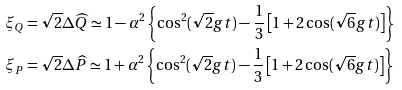Convert formula to latex. <formula><loc_0><loc_0><loc_500><loc_500>\xi _ { Q } & = \sqrt { 2 } \Delta \widehat { Q } \simeq 1 - \alpha ^ { 2 } \left \{ \cos ^ { 2 } ( \sqrt { 2 } g t ) - \frac { 1 } { 3 } \left [ 1 + 2 \cos ( \sqrt { 6 } g t ) \right ] \right \} \\ \xi _ { P } & = \sqrt { 2 } \Delta \widehat { P } \simeq 1 + \alpha ^ { 2 } \left \{ \cos ^ { 2 } ( \sqrt { 2 } g t ) - \frac { 1 } { 3 } \left [ 1 + 2 \cos ( \sqrt { 6 } g t ) \right ] \right \}</formula> 